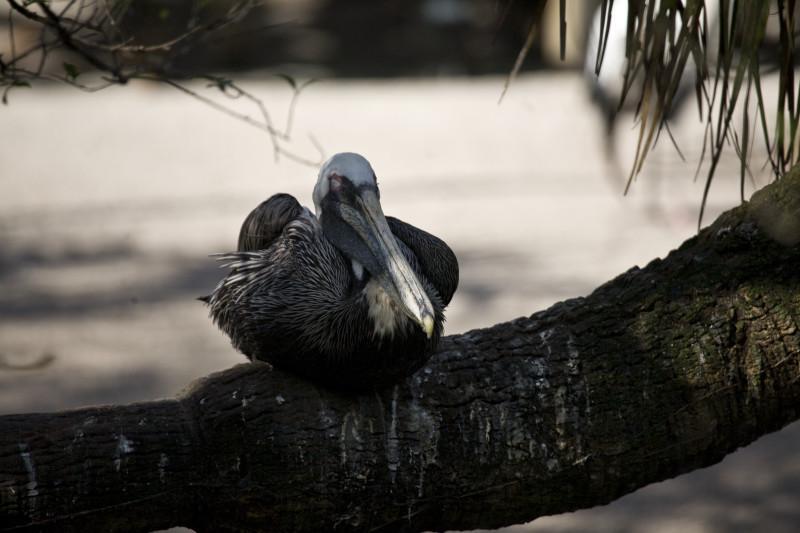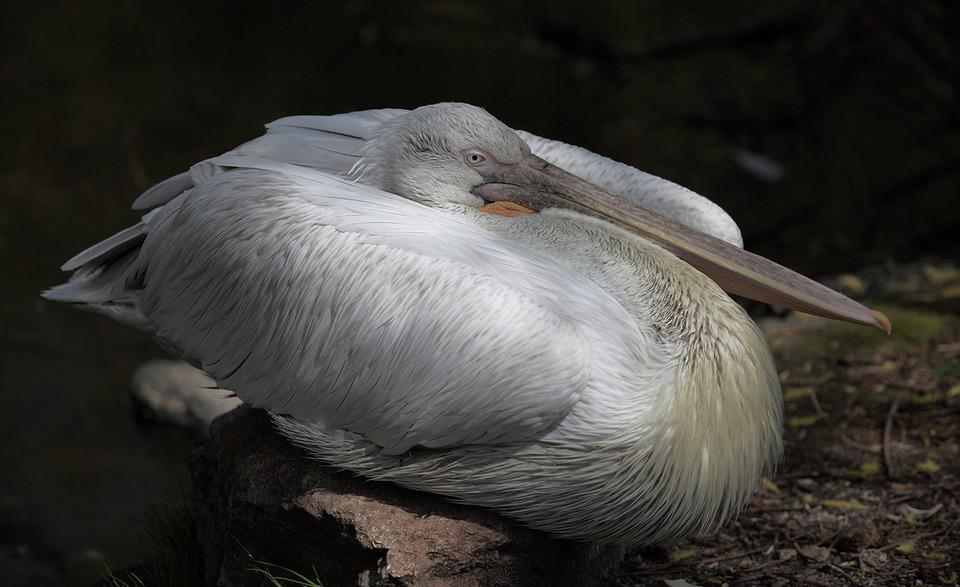The first image is the image on the left, the second image is the image on the right. For the images shown, is this caption "Each image shows a pelican posed with its head and body flattened, and in one image a pelican is sitting atop a flat post." true? Answer yes or no. No. The first image is the image on the left, the second image is the image on the right. For the images shown, is this caption "One bird is on a pole pointed to the right." true? Answer yes or no. No. 